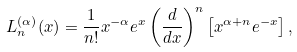Convert formula to latex. <formula><loc_0><loc_0><loc_500><loc_500>L _ { n } ^ { ( \alpha ) } ( x ) = \frac { 1 } { n ! } x ^ { - \alpha } e ^ { x } \left ( \frac { d } { d x } \right ) ^ { n } \left [ x ^ { \alpha + n } e ^ { - x } \right ] ,</formula> 